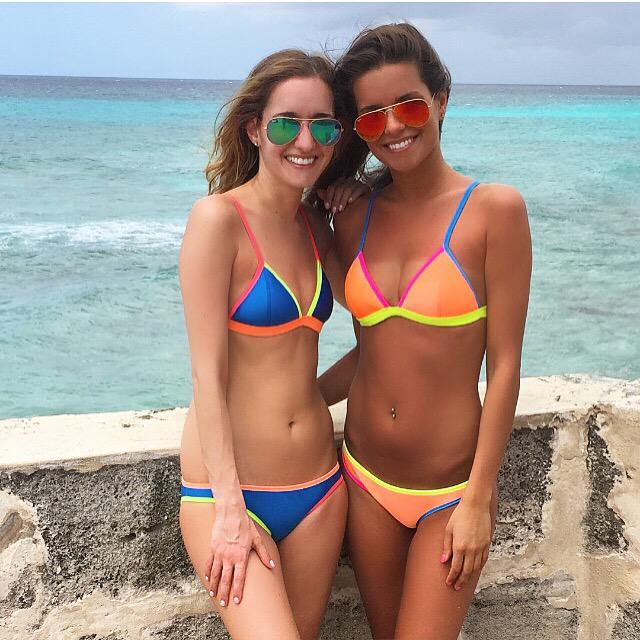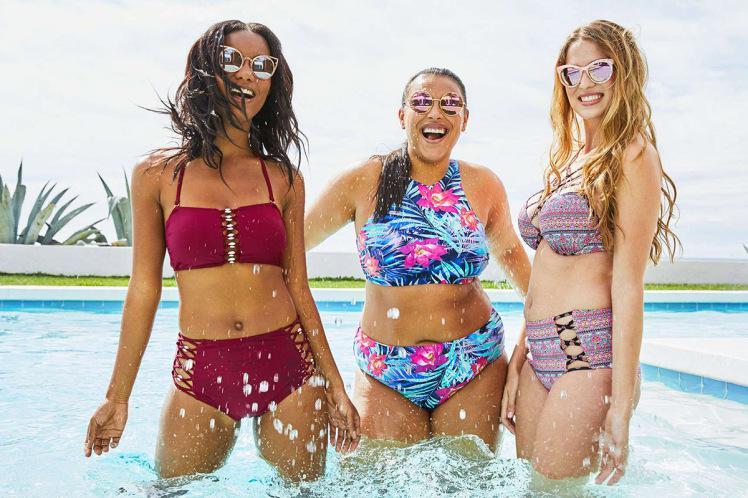The first image is the image on the left, the second image is the image on the right. Analyze the images presented: Is the assertion "One image contains exactly three bikini models, and the other image contains no more than two bikini models and includes a blue bikini bottom and an orange bikini top." valid? Answer yes or no. Yes. The first image is the image on the left, the second image is the image on the right. Analyze the images presented: Is the assertion "One of the images contains exactly two women in swimsuits." valid? Answer yes or no. Yes. 